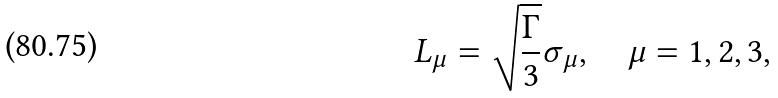<formula> <loc_0><loc_0><loc_500><loc_500>L _ { \mu } = \sqrt { \frac { \Gamma } { 3 } } \sigma _ { \mu } , \quad \mu = 1 , 2 , 3 ,</formula> 